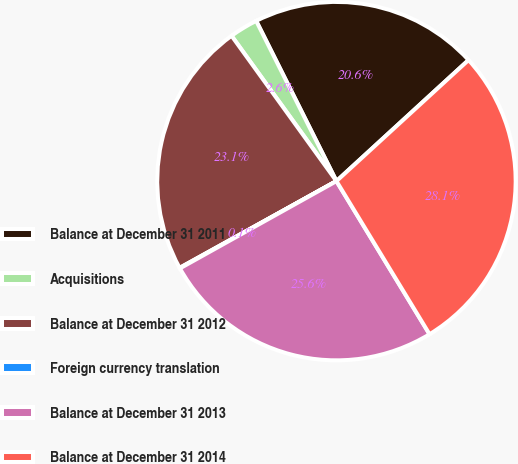Convert chart to OTSL. <chart><loc_0><loc_0><loc_500><loc_500><pie_chart><fcel>Balance at December 31 2011<fcel>Acquisitions<fcel>Balance at December 31 2012<fcel>Foreign currency translation<fcel>Balance at December 31 2013<fcel>Balance at December 31 2014<nl><fcel>20.58%<fcel>2.56%<fcel>23.09%<fcel>0.05%<fcel>25.6%<fcel>28.11%<nl></chart> 